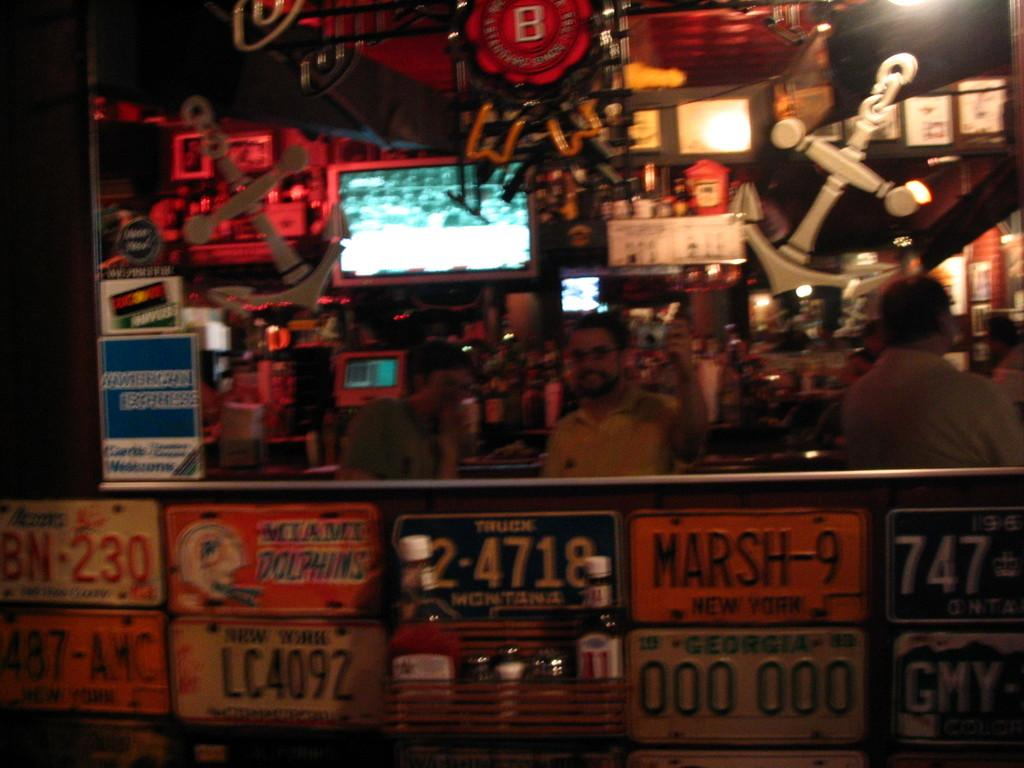What can be seen on the shelves in the image? There are books arranged on shelves in the image. Who or what else is present in the image? There are persons and other objects in the image. What is the color of the background in the image? The background of the image is dark in color. What type of church can be seen in the image? There is no church present in the image. How many women are visible in the image? The provided facts do not specify the number or gender of the persons present in the image. 